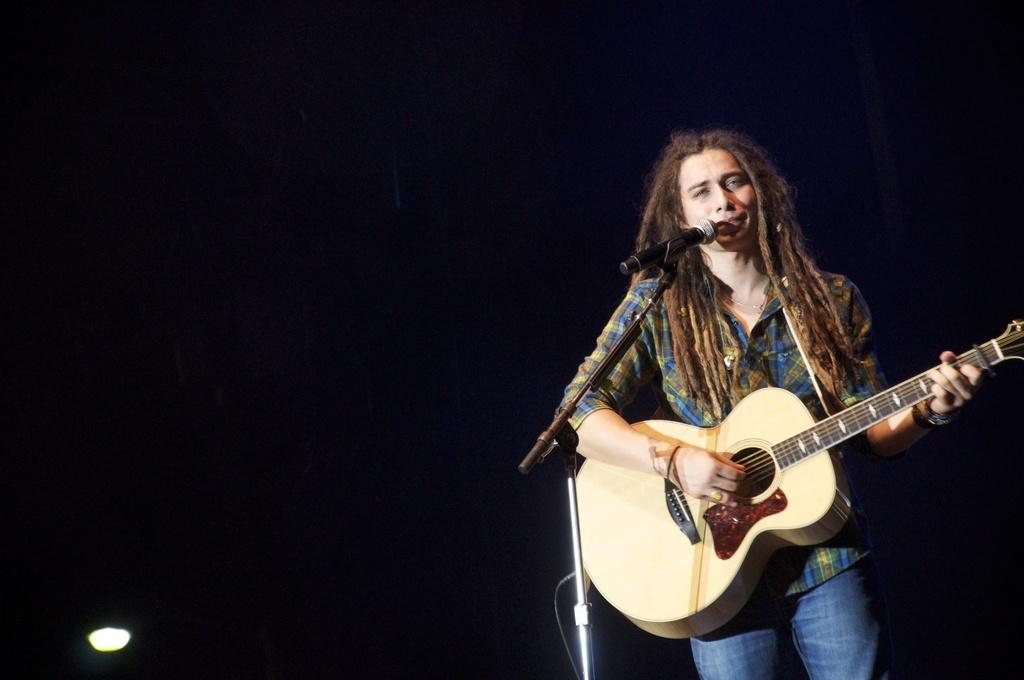What is the main subject of the image? There is a person in the image. What is the person doing in the image? The person is standing and singing into a microphone. What else is the person holding in the image? The person is holding a music instrument. What type of grain can be seen growing in the background of the image? There is no grain visible in the image; it features a person standing, singing, and holding a music instrument. 